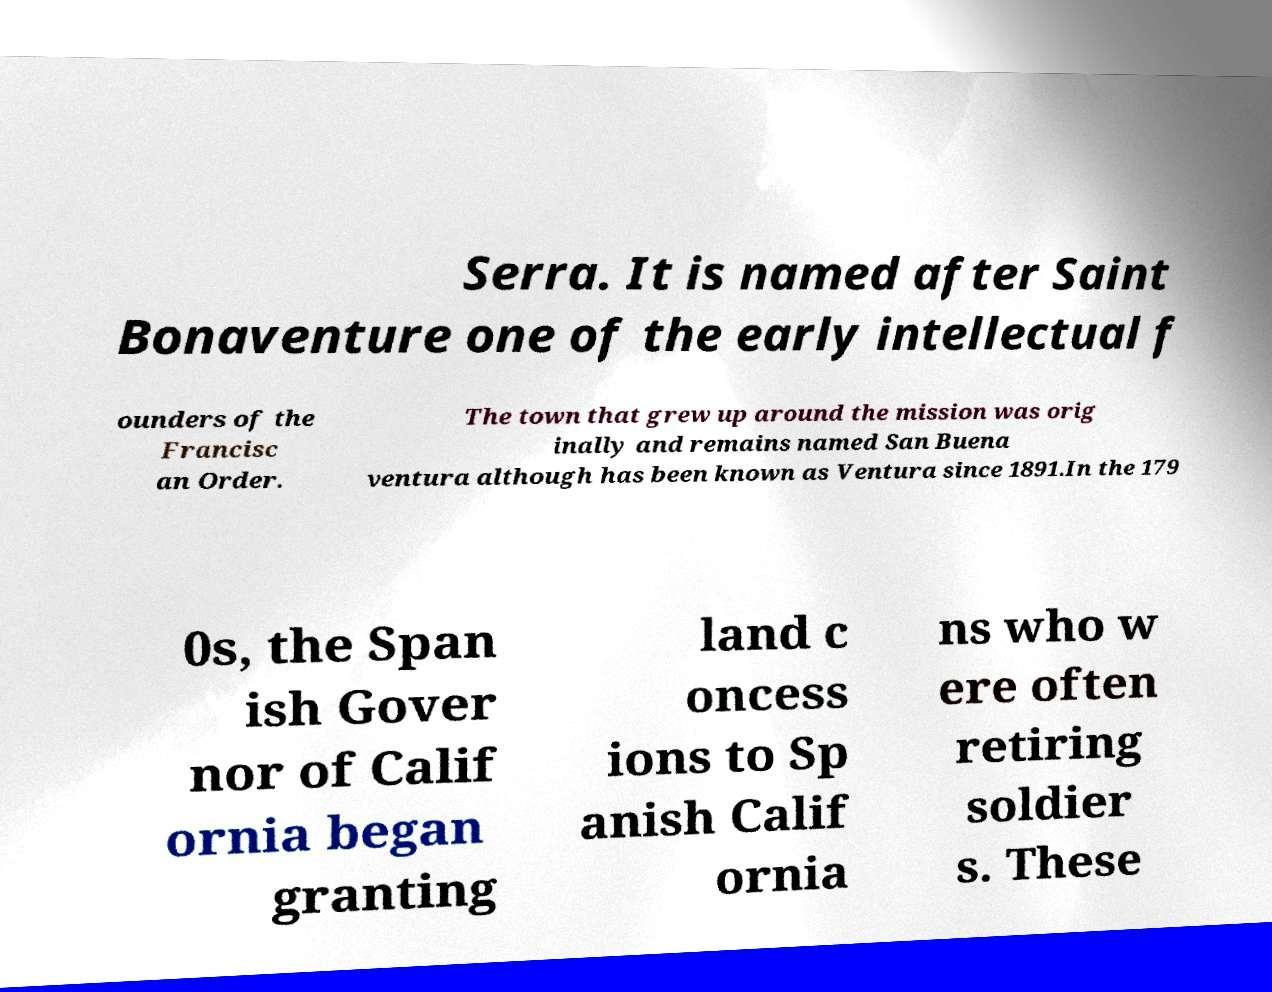Can you read and provide the text displayed in the image?This photo seems to have some interesting text. Can you extract and type it out for me? Serra. It is named after Saint Bonaventure one of the early intellectual f ounders of the Francisc an Order. The town that grew up around the mission was orig inally and remains named San Buena ventura although has been known as Ventura since 1891.In the 179 0s, the Span ish Gover nor of Calif ornia began granting land c oncess ions to Sp anish Calif ornia ns who w ere often retiring soldier s. These 